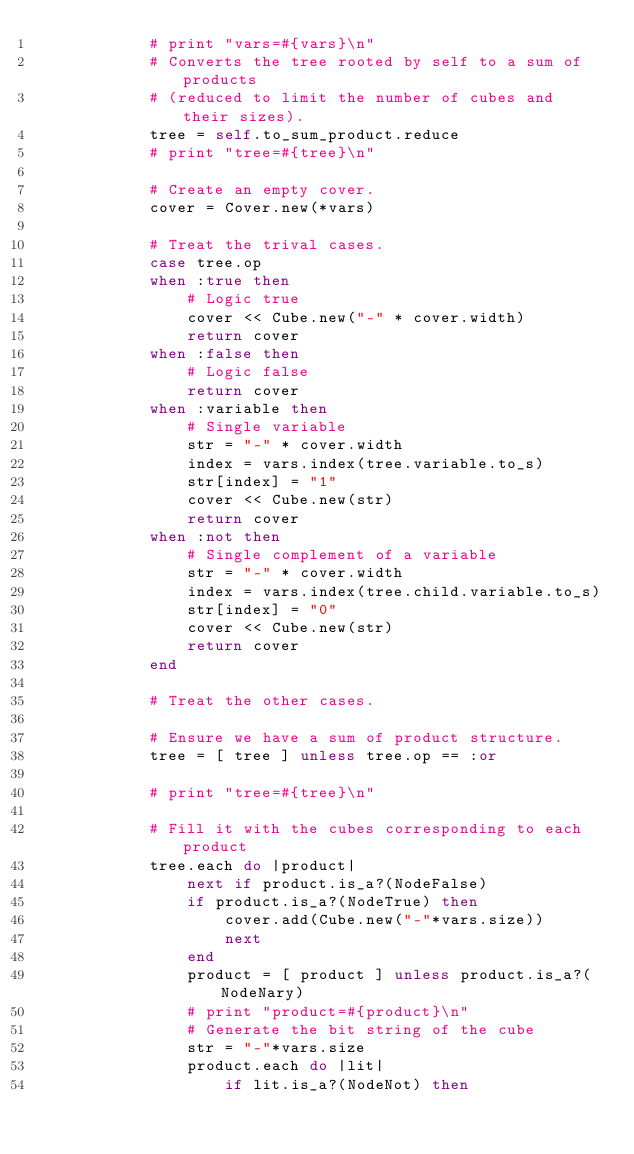<code> <loc_0><loc_0><loc_500><loc_500><_Ruby_>            # print "vars=#{vars}\n"
            # Converts the tree rooted by self to a sum of products
            # (reduced to limit the number of cubes and their sizes).
            tree = self.to_sum_product.reduce
            # print "tree=#{tree}\n"
            
            # Create an empty cover.
            cover = Cover.new(*vars)

            # Treat the trival cases.
            case tree.op 
            when :true then
                # Logic true
                cover << Cube.new("-" * cover.width)
                return cover
            when :false then
                # Logic false
                return cover
            when :variable then
                # Single variable
                str = "-" * cover.width
                index = vars.index(tree.variable.to_s)
                str[index] = "1"
                cover << Cube.new(str)
                return cover
            when :not then
                # Single complement of a variable
                str = "-" * cover.width
                index = vars.index(tree.child.variable.to_s)
                str[index] = "0"
                cover << Cube.new(str)
                return cover
            end

            # Treat the other cases.

            # Ensure we have a sum of product structure.
            tree = [ tree ] unless tree.op == :or

            # print "tree=#{tree}\n"

            # Fill it with the cubes corresponding to each product
            tree.each do |product|
                next if product.is_a?(NodeFalse)
                if product.is_a?(NodeTrue) then
                    cover.add(Cube.new("-"*vars.size))
                    next
                end
                product = [ product ] unless product.is_a?(NodeNary)
                # print "product=#{product}\n"
                # Generate the bit string of the cube
                str = "-"*vars.size
                product.each do |lit|
                    if lit.is_a?(NodeNot) then</code> 